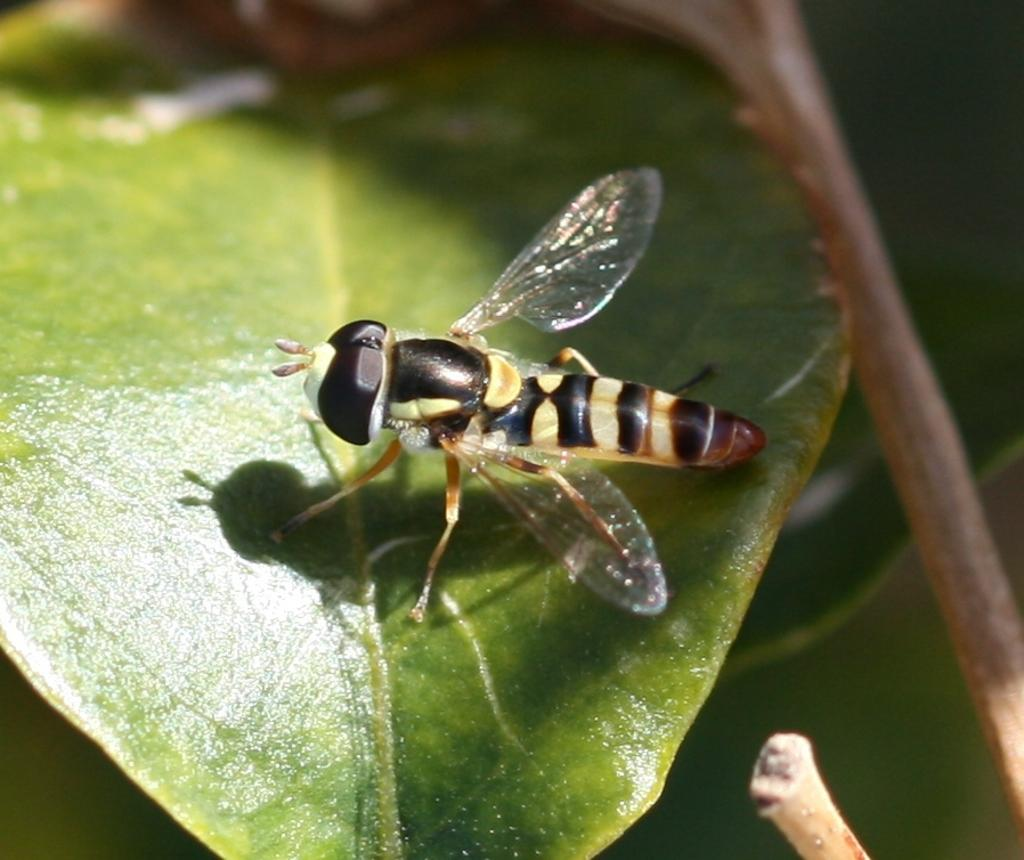What is the main subject of the picture? The main subject of the picture is an insect. Where is the insect located in the image? The insect is sitting on a leaf. Can you describe the background of the image? The background of the image is blurred. What type of seashore can be seen in the background of the image? There is no seashore present in the image; the background is blurred. How many points does the insect have on its body in the image? The number of points on the insect's body cannot be determined from the image alone, as it is not a clear enough image to count the points. 